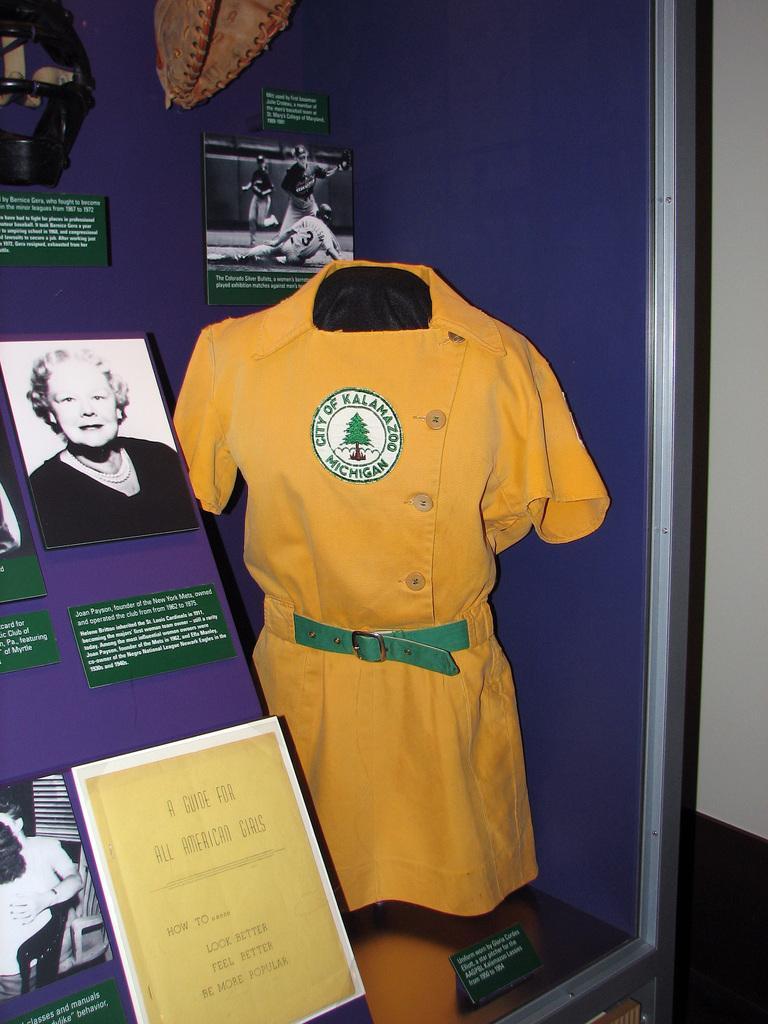Could you give a brief overview of what you see in this image? In this picture I can see a mannequin with a dress. I can see boards and some other objects. 